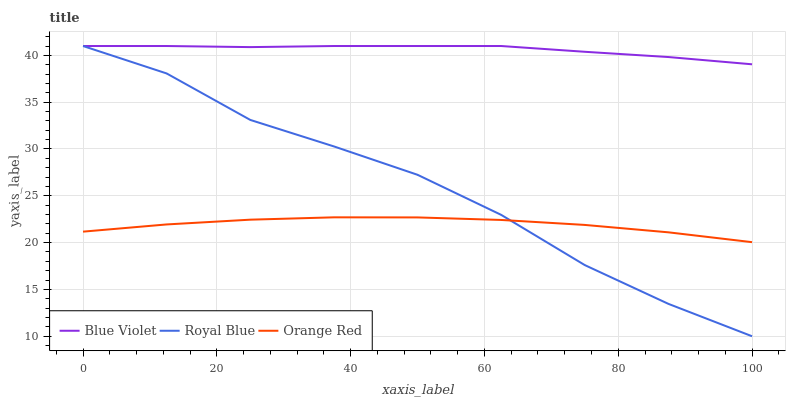Does Orange Red have the minimum area under the curve?
Answer yes or no. Yes. Does Blue Violet have the maximum area under the curve?
Answer yes or no. Yes. Does Blue Violet have the minimum area under the curve?
Answer yes or no. No. Does Orange Red have the maximum area under the curve?
Answer yes or no. No. Is Blue Violet the smoothest?
Answer yes or no. Yes. Is Royal Blue the roughest?
Answer yes or no. Yes. Is Orange Red the smoothest?
Answer yes or no. No. Is Orange Red the roughest?
Answer yes or no. No. Does Royal Blue have the lowest value?
Answer yes or no. Yes. Does Orange Red have the lowest value?
Answer yes or no. No. Does Blue Violet have the highest value?
Answer yes or no. Yes. Does Orange Red have the highest value?
Answer yes or no. No. Is Orange Red less than Blue Violet?
Answer yes or no. Yes. Is Blue Violet greater than Orange Red?
Answer yes or no. Yes. Does Royal Blue intersect Orange Red?
Answer yes or no. Yes. Is Royal Blue less than Orange Red?
Answer yes or no. No. Is Royal Blue greater than Orange Red?
Answer yes or no. No. Does Orange Red intersect Blue Violet?
Answer yes or no. No. 